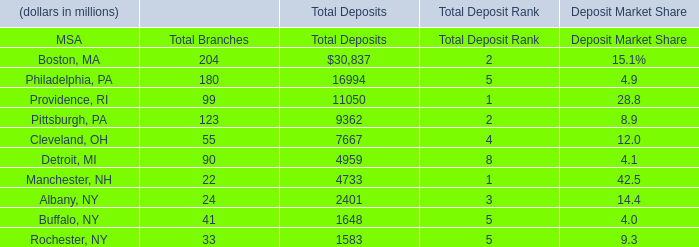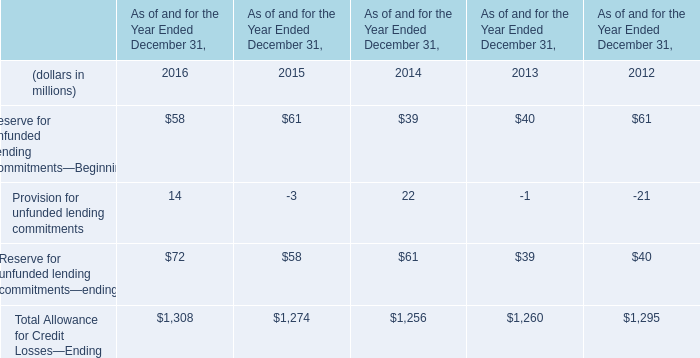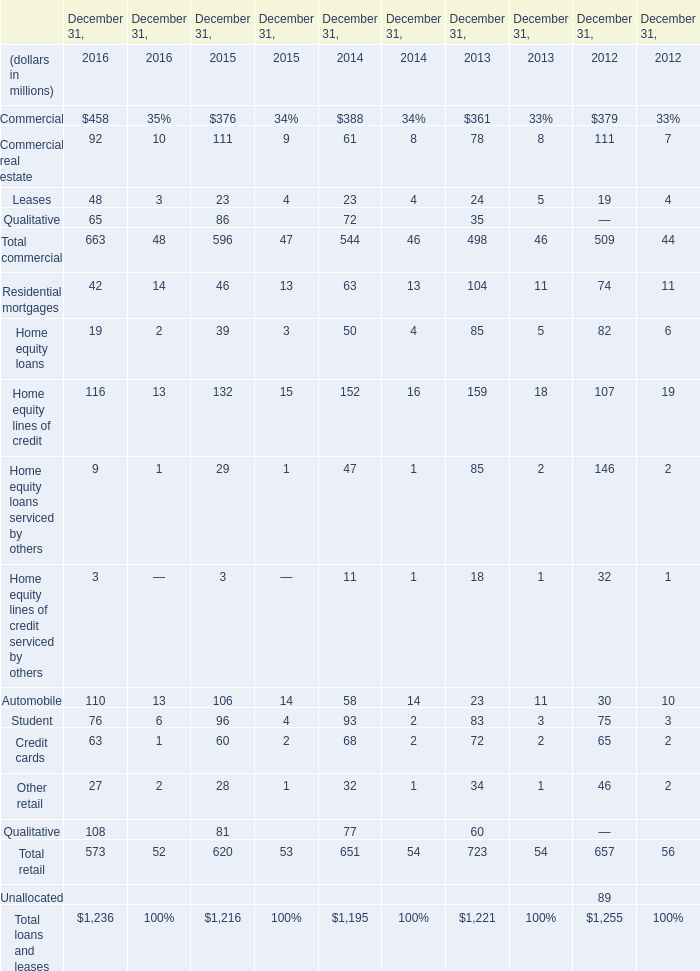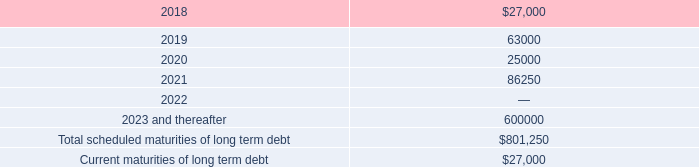what was the percentage change in interest expense net from 2015 to 2016? 
Computations: ((26.4 - 14.6) / 14.6)
Answer: 0.80822. 